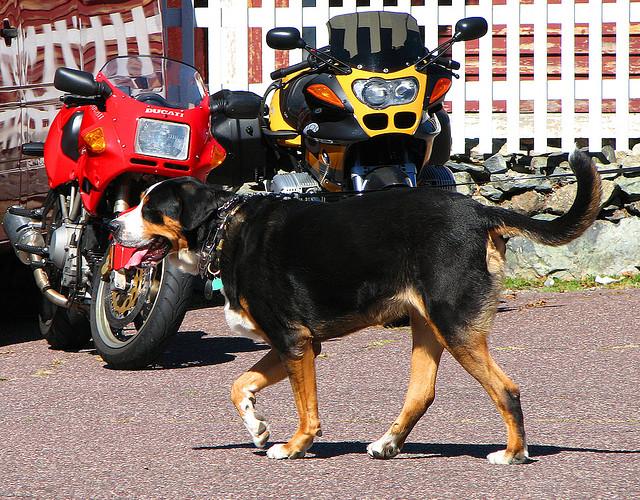What kind of fence is in the background?
Give a very brief answer. Picket. How many motorbikes are near the dog?
Concise answer only. 2. Does the dog have it's mouth shut?
Short answer required. No. 